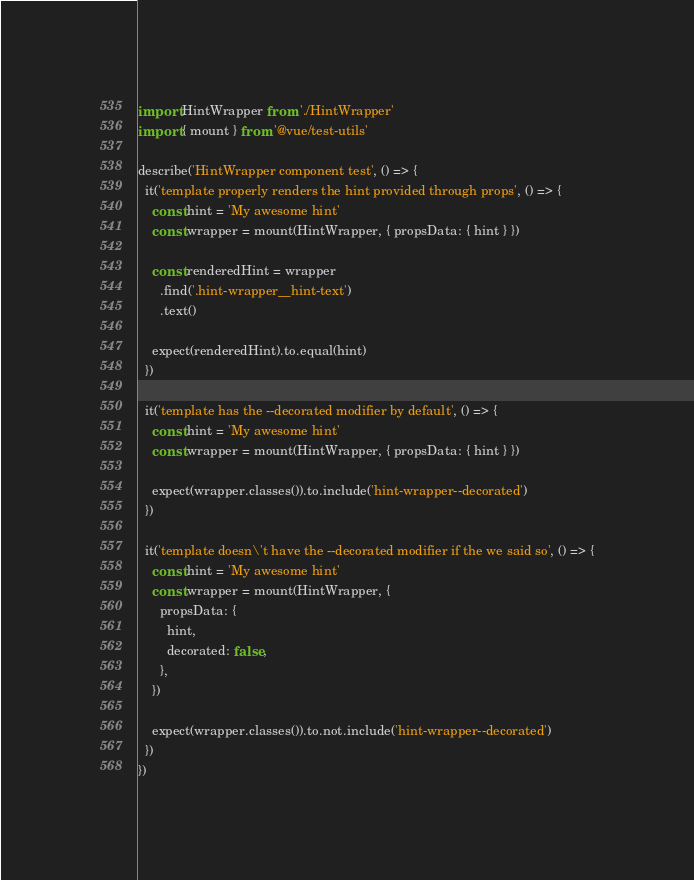<code> <loc_0><loc_0><loc_500><loc_500><_JavaScript_>import HintWrapper from './HintWrapper'
import { mount } from '@vue/test-utils'

describe('HintWrapper component test', () => {
  it('template properly renders the hint provided through props', () => {
    const hint = 'My awesome hint'
    const wrapper = mount(HintWrapper, { propsData: { hint } })

    const renderedHint = wrapper
      .find('.hint-wrapper__hint-text')
      .text()

    expect(renderedHint).to.equal(hint)
  })

  it('template has the --decorated modifier by default', () => {
    const hint = 'My awesome hint'
    const wrapper = mount(HintWrapper, { propsData: { hint } })

    expect(wrapper.classes()).to.include('hint-wrapper--decorated')
  })

  it('template doesn\'t have the --decorated modifier if the we said so', () => {
    const hint = 'My awesome hint'
    const wrapper = mount(HintWrapper, {
      propsData: {
        hint,
        decorated: false,
      },
    })

    expect(wrapper.classes()).to.not.include('hint-wrapper--decorated')
  })
})
</code> 